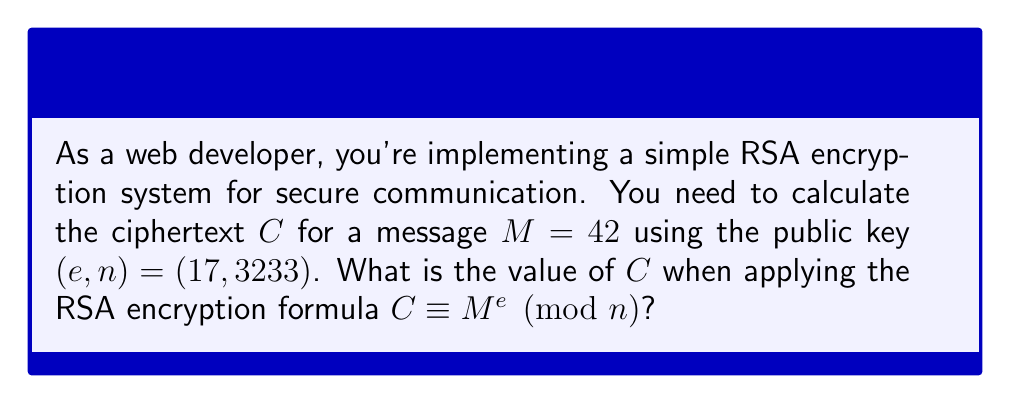Solve this math problem. To calculate the ciphertext $C$, we need to use modular exponentiation. The formula is:

$$C \equiv M^e \pmod{n}$$

Where:
$M = 42$ (the message)
$e = 17$ (the public exponent)
$n = 3233$ (the modulus)

We need to calculate $42^{17} \pmod{3233}$. This is a large number, so we'll use the square-and-multiply algorithm:

1) Convert the exponent (17) to binary: $17_{10} = 10001_2$

2) Start with the result $r = 1$ and $base = 42$

3) For each bit in the binary exponent (from left to right):
   a) Square the result: $r = r^2 \pmod{3233}$
   b) If the bit is 1, multiply by the base: $r = r \times base \pmod{3233}$

Step-by-step calculation:
- Initial: $r = 1$
- Bit 1: $r = 1^2 \times 42 = 42 \pmod{3233}$
- Bit 0: $r = 42^2 = 1764 \pmod{3233}$
- Bit 0: $r = 1764^2 = 3108096 \equiv 2531 \pmod{3233}$
- Bit 0: $r = 2531^2 = 6405961 \equiv 1525 \pmod{3233}$
- Bit 1: $r = 1525^2 \times 42 = 2325625 \times 42 \equiv 2312 \times 42 = 97104 \equiv 2688 \pmod{3233}$

Therefore, the ciphertext $C = 2688$.
Answer: $2688$ 